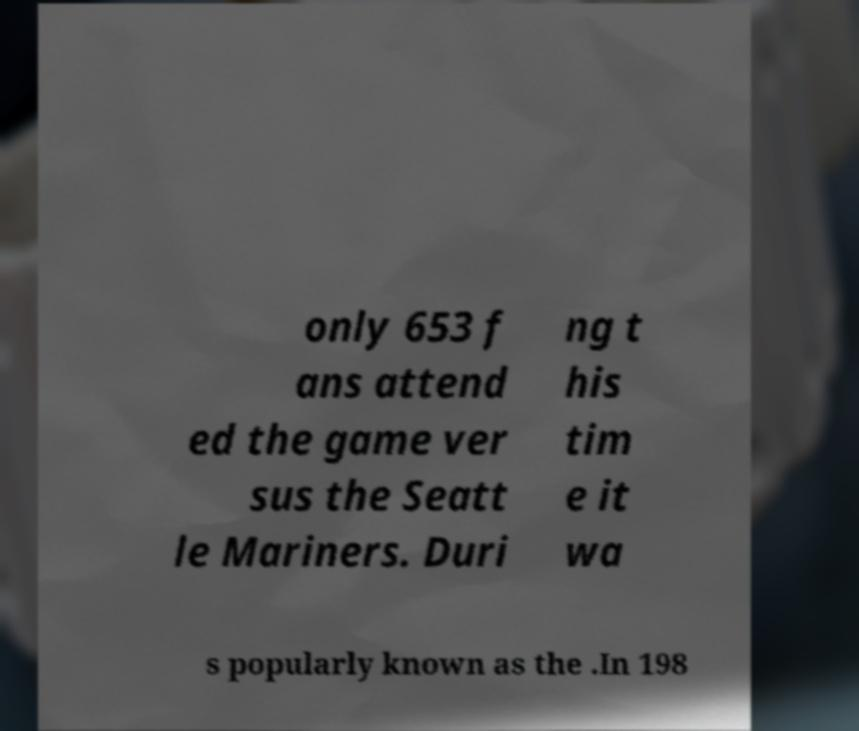Please identify and transcribe the text found in this image. only 653 f ans attend ed the game ver sus the Seatt le Mariners. Duri ng t his tim e it wa s popularly known as the .In 198 